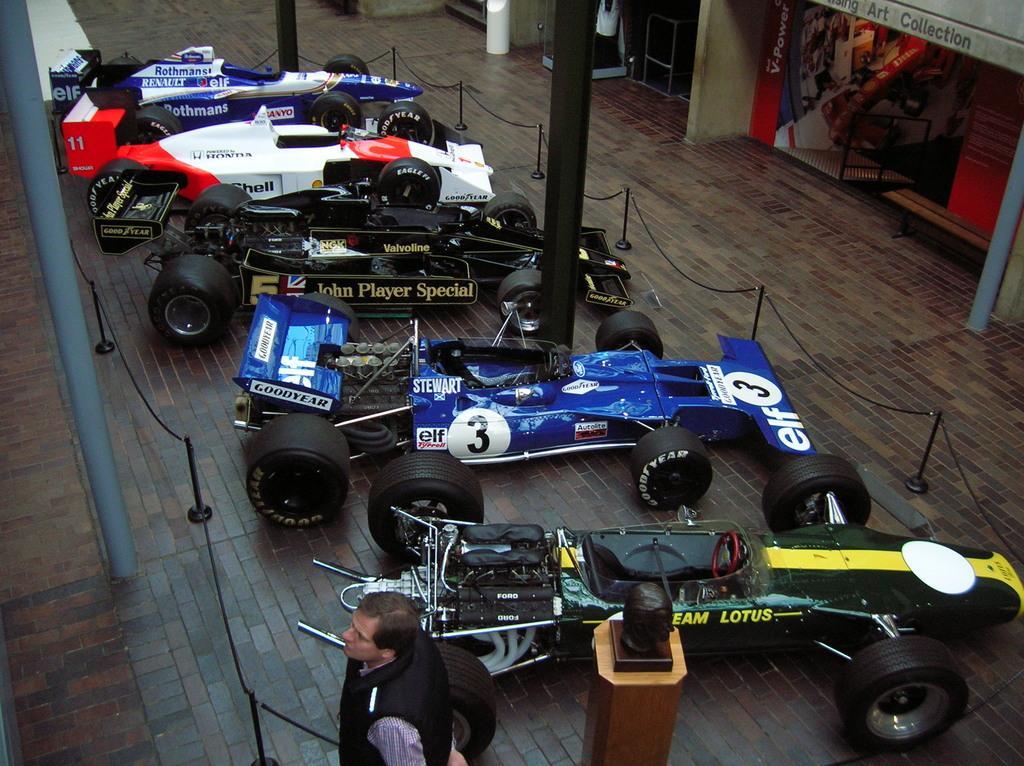In one or two sentences, can you explain what this image depicts? In this image I can see there is a person standing. And beside him there is a statue. And there are race cars on the ground. In front of the cars there a rope tied to the rod. And there is a pillar and a banner. And there are stairs and a stand. 